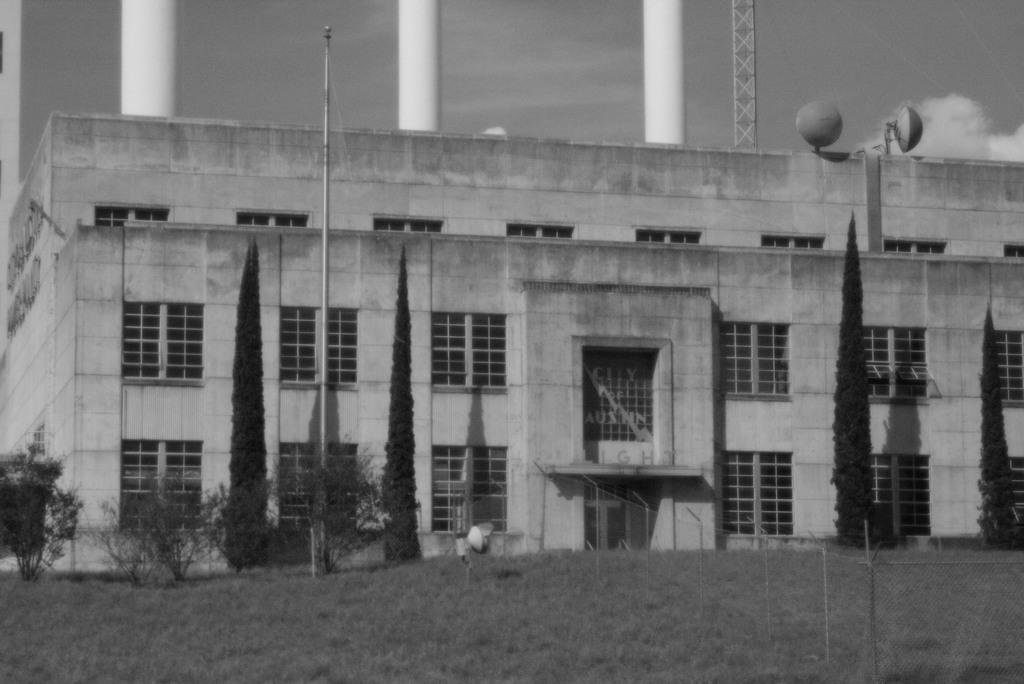What is the color scheme of the image? The image is black and white. What can be seen in the background of the image? There is a building in the background of the image. What type of vegetation is present in front of the building? Trees are present in front of the building. What type of terrain is the trees located on? The trees are on a grassland. What is visible in the sky in the image? The sky is visible in the image, and clouds are present. What type of crayon is being used to draw on the building in the image? There is no crayon or drawing present on the building in the image. What type of crime is being committed in the image? There is no crime or criminal activity depicted in the image. 